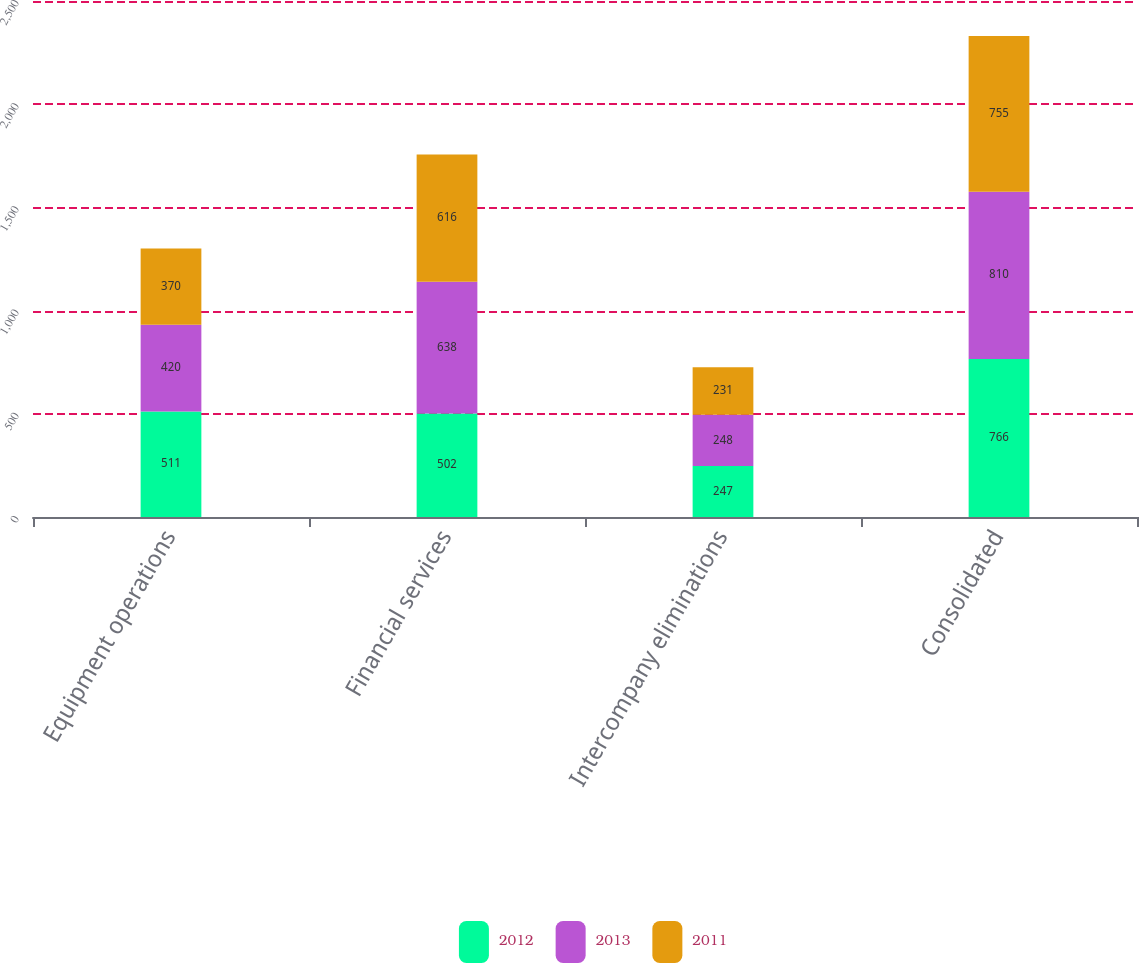Convert chart to OTSL. <chart><loc_0><loc_0><loc_500><loc_500><stacked_bar_chart><ecel><fcel>Equipment operations<fcel>Financial services<fcel>Intercompany eliminations<fcel>Consolidated<nl><fcel>2012<fcel>511<fcel>502<fcel>247<fcel>766<nl><fcel>2013<fcel>420<fcel>638<fcel>248<fcel>810<nl><fcel>2011<fcel>370<fcel>616<fcel>231<fcel>755<nl></chart> 